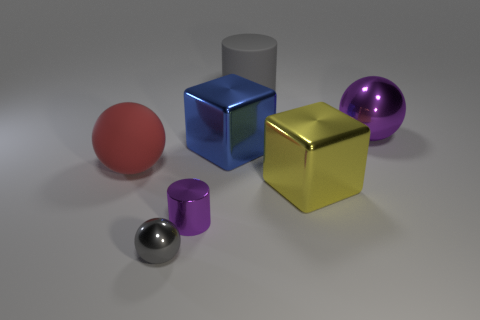Subtract all red matte balls. How many balls are left? 2 Add 2 tiny red shiny cylinders. How many objects exist? 9 Subtract all gray spheres. How many spheres are left? 2 Subtract all cubes. How many objects are left? 5 Subtract 2 cylinders. How many cylinders are left? 0 Subtract 1 gray cylinders. How many objects are left? 6 Subtract all cyan cubes. Subtract all red cylinders. How many cubes are left? 2 Subtract all green cubes. How many cyan balls are left? 0 Subtract all tiny purple shiny cylinders. Subtract all purple objects. How many objects are left? 4 Add 7 purple shiny balls. How many purple shiny balls are left? 8 